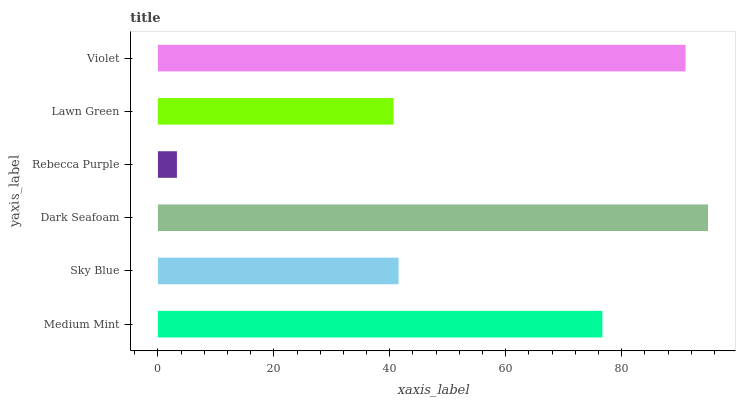Is Rebecca Purple the minimum?
Answer yes or no. Yes. Is Dark Seafoam the maximum?
Answer yes or no. Yes. Is Sky Blue the minimum?
Answer yes or no. No. Is Sky Blue the maximum?
Answer yes or no. No. Is Medium Mint greater than Sky Blue?
Answer yes or no. Yes. Is Sky Blue less than Medium Mint?
Answer yes or no. Yes. Is Sky Blue greater than Medium Mint?
Answer yes or no. No. Is Medium Mint less than Sky Blue?
Answer yes or no. No. Is Medium Mint the high median?
Answer yes or no. Yes. Is Sky Blue the low median?
Answer yes or no. Yes. Is Dark Seafoam the high median?
Answer yes or no. No. Is Violet the low median?
Answer yes or no. No. 